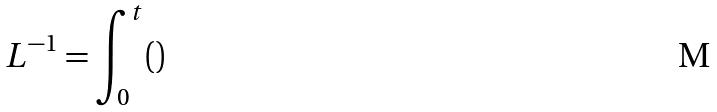<formula> <loc_0><loc_0><loc_500><loc_500>L ^ { - 1 } = \int _ { 0 } ^ { t } ( )</formula> 